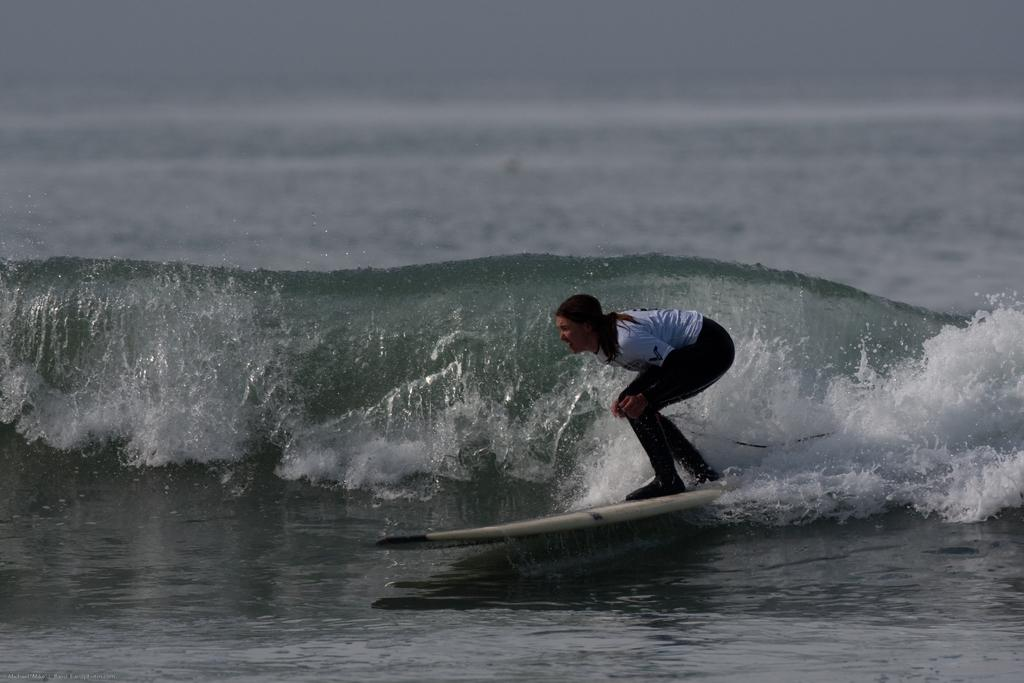What is the main subject of the image? There is a person in the image. What is the person doing in the image? The person is standing on a surfboard. What type of environment is visible in the image? There is water visible in the image. What type of calculator can be seen floating in the water in the image? There is no calculator present in the image; it features a person standing on a surfboard in water. Can you tell me how many pickles are visible on the surfboard? There are no pickles present on the surfboard or in the image. 